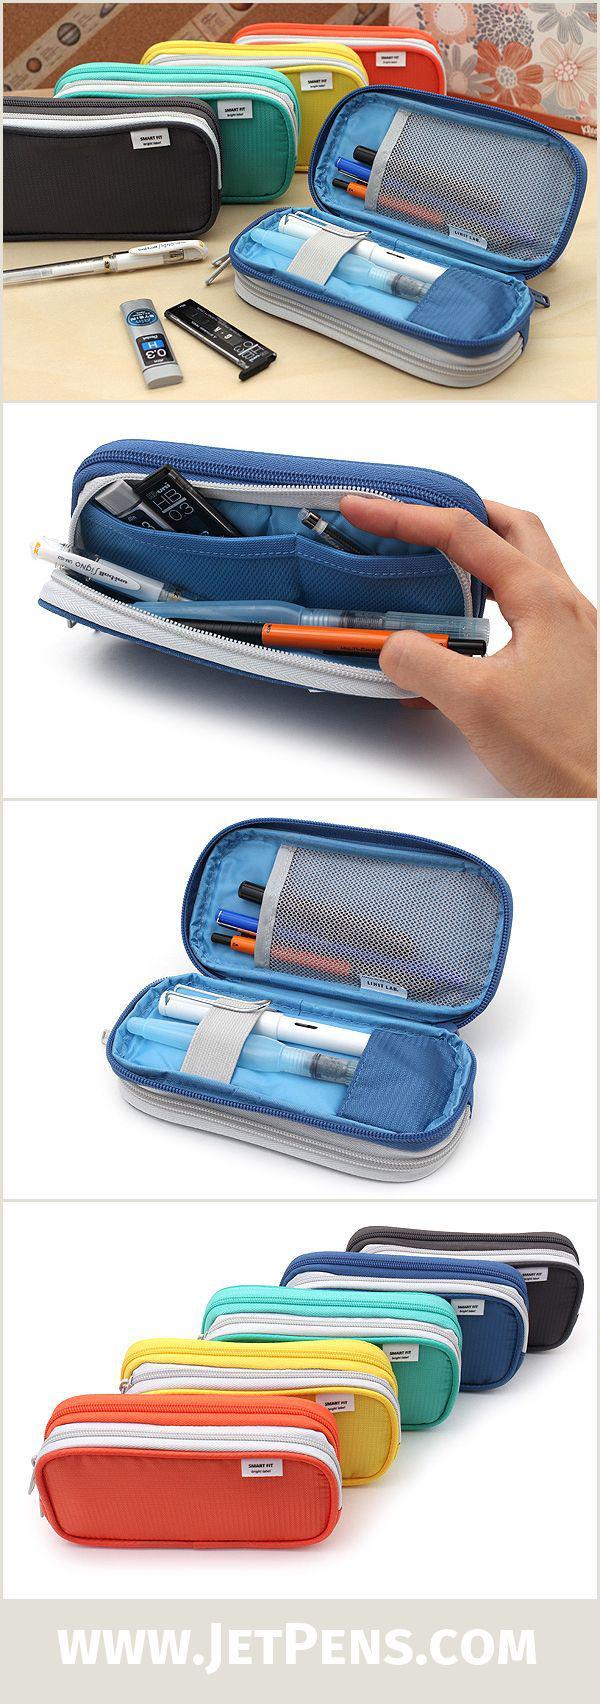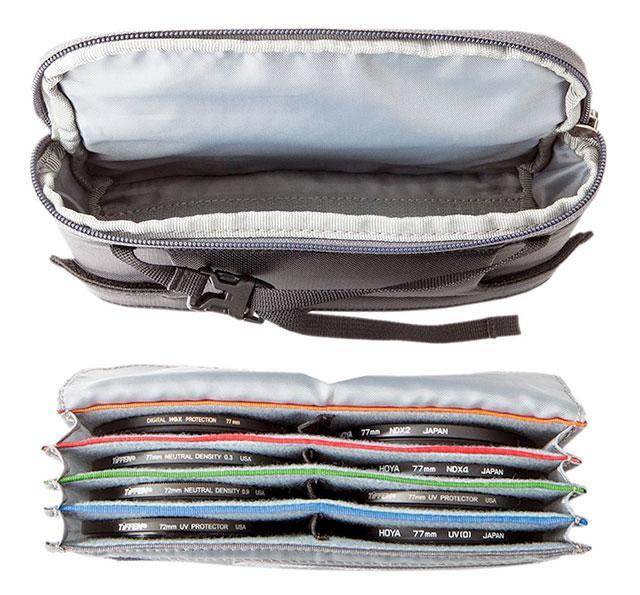The first image is the image on the left, the second image is the image on the right. Examine the images to the left and right. Is the description "Two blue cases are open, exposing the contents." accurate? Answer yes or no. No. The first image is the image on the left, the second image is the image on the right. Evaluate the accuracy of this statement regarding the images: "An image shows a hand opening a blue pencil case.". Is it true? Answer yes or no. Yes. 